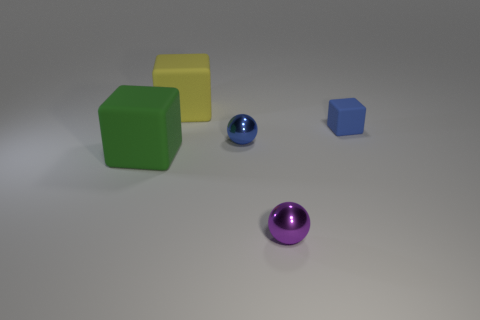There is a metallic sphere that is the same color as the small rubber thing; what size is it?
Make the answer very short. Small. What number of other things are there of the same size as the green block?
Your answer should be very brief. 1. There is a tiny rubber thing; is it the same color as the metal object in front of the green thing?
Ensure brevity in your answer.  No. Are there fewer tiny purple things on the left side of the small purple sphere than small shiny objects that are in front of the big green block?
Keep it short and to the point. Yes. There is a thing that is in front of the small blue shiny object and right of the yellow cube; what color is it?
Provide a succinct answer. Purple. There is a green matte cube; is its size the same as the metallic object that is in front of the blue metal ball?
Your answer should be compact. No. What is the shape of the big matte thing behind the blue matte cube?
Make the answer very short. Cube. Are there more large green matte things that are behind the tiny blue rubber cube than large cyan cylinders?
Ensure brevity in your answer.  No. What number of purple metallic things are behind the large matte object in front of the tiny metal ball behind the green rubber block?
Ensure brevity in your answer.  0. There is a thing that is on the right side of the purple metallic object; is it the same size as the thing behind the blue cube?
Your answer should be compact. No. 